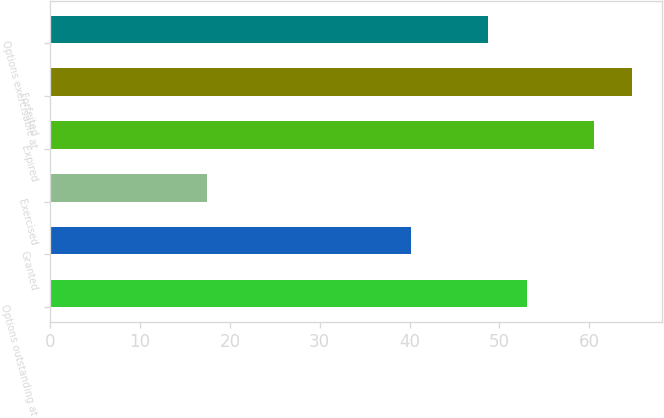<chart> <loc_0><loc_0><loc_500><loc_500><bar_chart><fcel>Options outstanding at<fcel>Granted<fcel>Exercised<fcel>Expired<fcel>Forfeited<fcel>Options exercisable at<nl><fcel>53.07<fcel>40.11<fcel>17.43<fcel>60.48<fcel>64.8<fcel>48.75<nl></chart> 